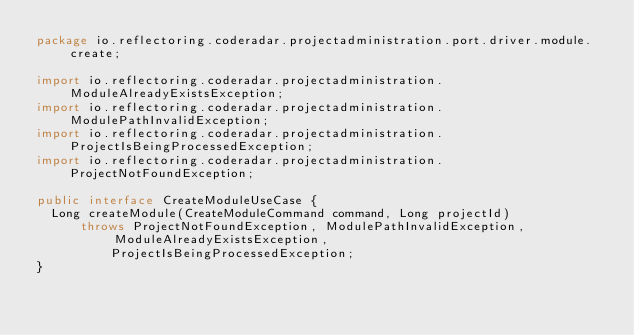<code> <loc_0><loc_0><loc_500><loc_500><_Java_>package io.reflectoring.coderadar.projectadministration.port.driver.module.create;

import io.reflectoring.coderadar.projectadministration.ModuleAlreadyExistsException;
import io.reflectoring.coderadar.projectadministration.ModulePathInvalidException;
import io.reflectoring.coderadar.projectadministration.ProjectIsBeingProcessedException;
import io.reflectoring.coderadar.projectadministration.ProjectNotFoundException;

public interface CreateModuleUseCase {
  Long createModule(CreateModuleCommand command, Long projectId)
      throws ProjectNotFoundException, ModulePathInvalidException, ModuleAlreadyExistsException,
          ProjectIsBeingProcessedException;
}
</code> 